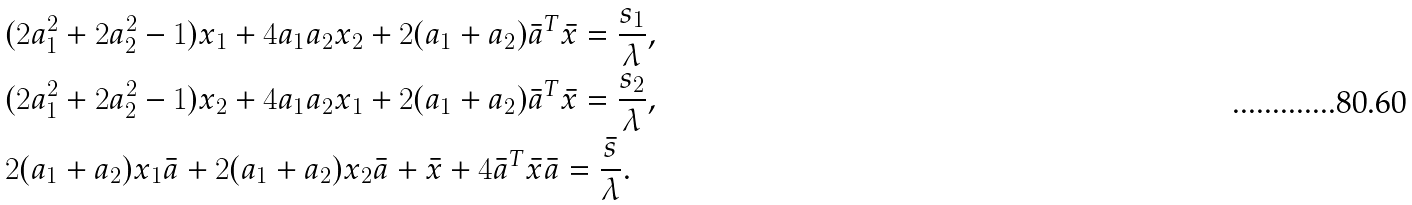Convert formula to latex. <formula><loc_0><loc_0><loc_500><loc_500>& ( 2 a _ { 1 } ^ { 2 } + 2 a _ { 2 } ^ { 2 } - 1 ) x _ { 1 } + 4 a _ { 1 } a _ { 2 } x _ { 2 } + 2 ( a _ { 1 } + a _ { 2 } ) \bar { a } ^ { T } \bar { x } = \frac { s _ { 1 } } { \lambda } , \\ & ( 2 a _ { 1 } ^ { 2 } + 2 a _ { 2 } ^ { 2 } - 1 ) x _ { 2 } + 4 a _ { 1 } a _ { 2 } x _ { 1 } + 2 ( a _ { 1 } + a _ { 2 } ) \bar { a } ^ { T } \bar { x } = \frac { s _ { 2 } } { \lambda } , \\ & 2 ( a _ { 1 } + a _ { 2 } ) x _ { 1 } \bar { a } + 2 ( a _ { 1 } + a _ { 2 } ) x _ { 2 } \bar { a } + \bar { x } + 4 \bar { a } ^ { T } \bar { x } \bar { a } = \frac { \bar { s } } { \lambda } .</formula> 